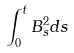<formula> <loc_0><loc_0><loc_500><loc_500>\int _ { 0 } ^ { t } B _ { s } ^ { 2 } d s</formula> 